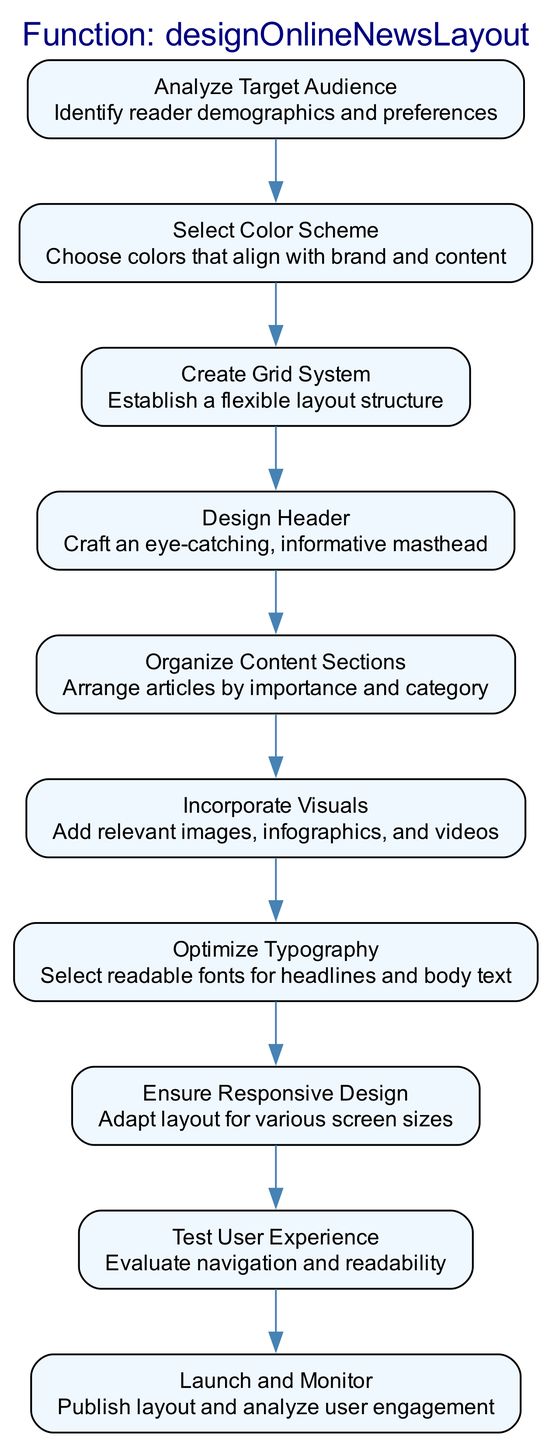What is the first step in the flow chart? The diagram lists "Analyze Target Audience" as the first step, which is the initial action taken before any other steps in the process.
Answer: Analyze Target Audience How many steps are there in total? By counting the individual steps represented as nodes in the diagram, there are 10 steps included in the flow.
Answer: 10 What step comes before "Incorporate Visuals"? The flow indicates that "Organize Content Sections" is the step that directly precedes "Incorporate Visuals," showing the order in which these tasks should be completed.
Answer: Organize Content Sections Which step focuses on adapting the layout for different devices? The step "Ensure Responsive Design" specifically addresses the need to adapt the layout for various screen sizes, which is crucial for online news design.
Answer: Ensure Responsive Design Which two steps are adjacent to "Launch and Monitor"? The diagram shows that "Test User Experience" directly precedes "Launch and Monitor" and there are no other steps following "Launch and Monitor," making them the adjacent steps in the flow sequence.
Answer: Test User Experience and Launch and Monitor Which steps are involved in the visualization process? The steps "Incorporate Visuals" and "Select Color Scheme" are both related to the visualization aspect of the news layout, focusing on image and color choices respectively.
Answer: Incorporate Visuals and Select Color Scheme What is the primary goal of the "Test User Experience" step? The purpose of this step is to evaluate navigation and readability, ensuring the intended audience can easily navigate and understand the layout before launch.
Answer: Evaluate navigation and readability How many edges connect the steps? The diagram visually connects each step with edges, indicating a directed flow; counting these edges reveals that there are nine edges connecting the ten steps.
Answer: 9 Which step requires an understanding of reader demographics? "Analyze Target Audience" is the step that specifically requires understanding reader demographics and preferences to tailor the news layout effectively.
Answer: Analyze Target Audience What is the last action taken in the design process? The final action listed in the diagram is "Launch and Monitor," which signifies the conclusion of the design process where the layout is published and user engagement is analyzed.
Answer: Launch and Monitor 